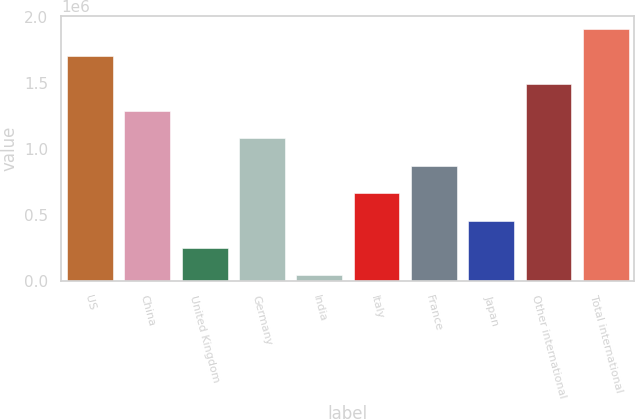<chart> <loc_0><loc_0><loc_500><loc_500><bar_chart><fcel>US<fcel>China<fcel>United Kingdom<fcel>Germany<fcel>India<fcel>Italy<fcel>France<fcel>Japan<fcel>Other international<fcel>Total international<nl><fcel>1.70119e+06<fcel>1.28687e+06<fcel>251054<fcel>1.0797e+06<fcel>43891<fcel>665379<fcel>872541<fcel>458216<fcel>1.49403e+06<fcel>1.90835e+06<nl></chart> 